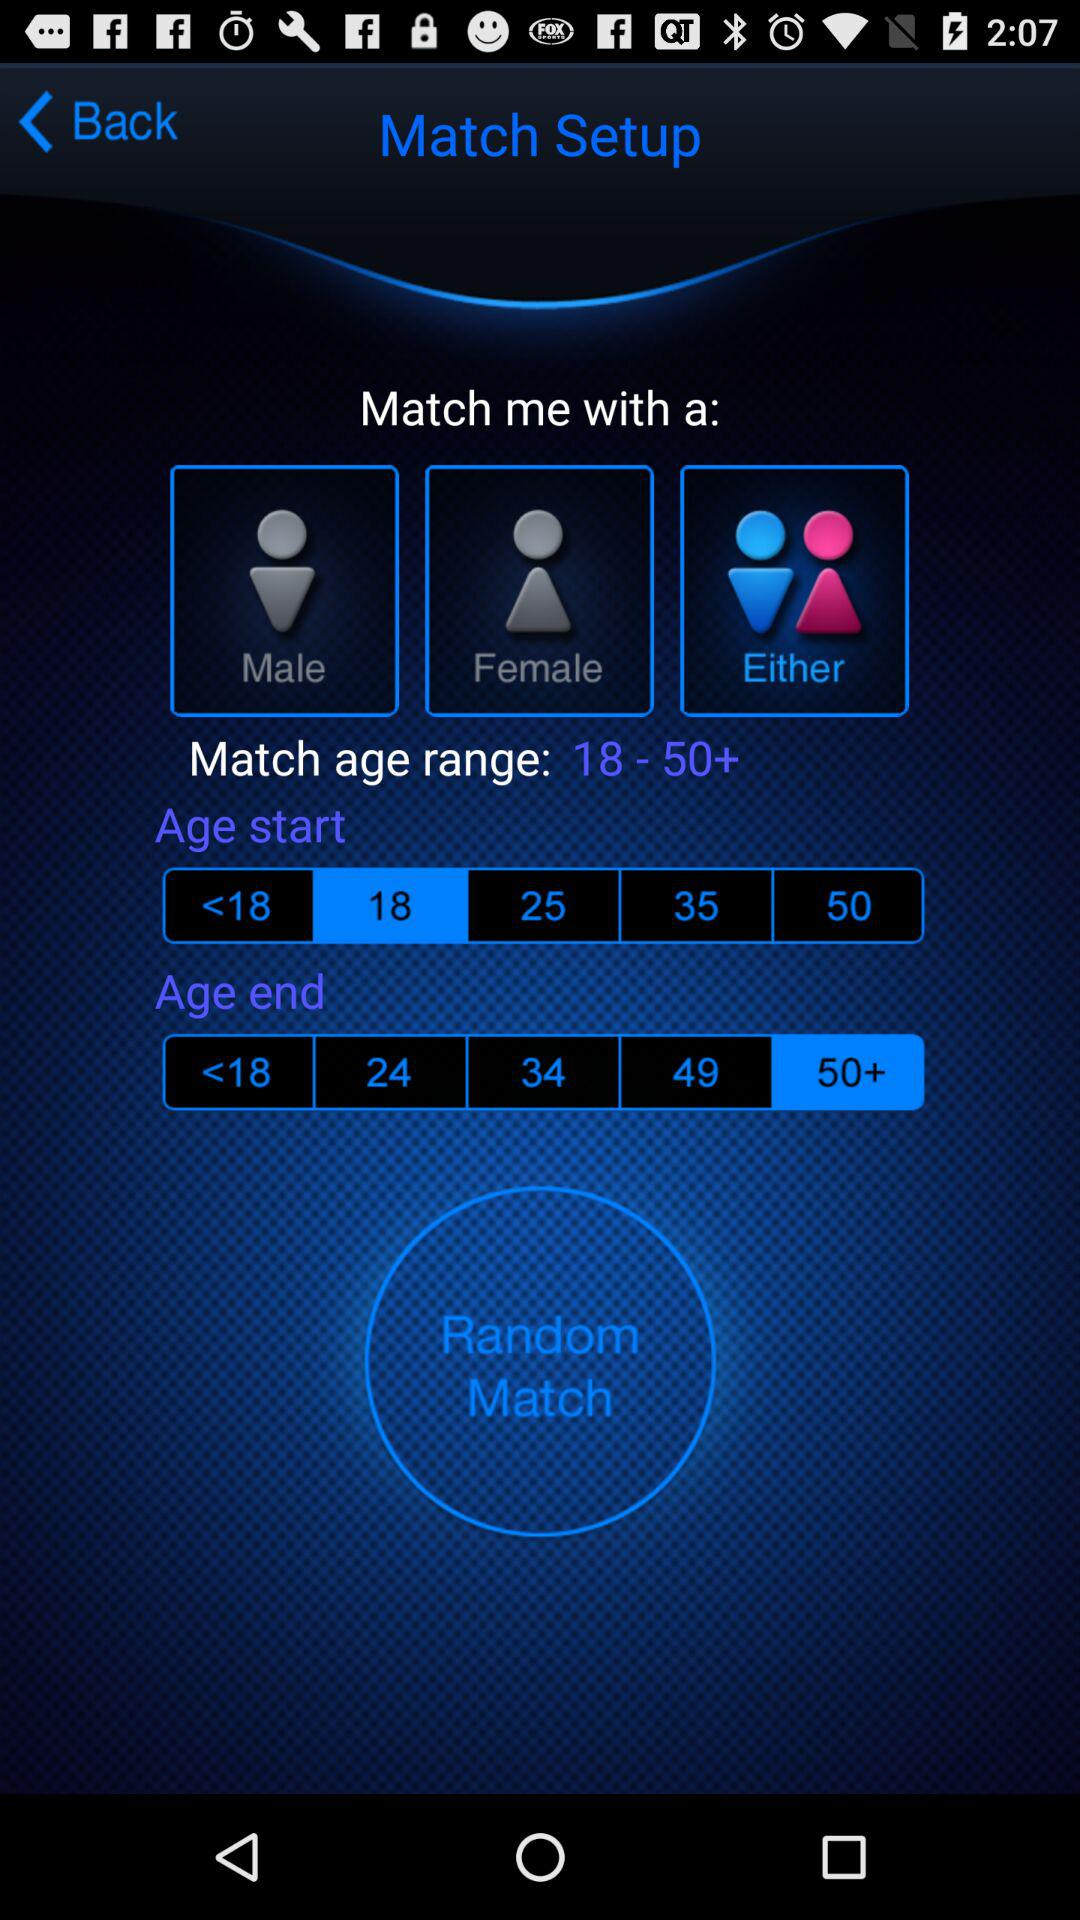What is the given age range for the match? The given age range for the match is from 18 to 50+. 